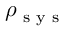Convert formula to latex. <formula><loc_0><loc_0><loc_500><loc_500>\rho _ { s y s }</formula> 